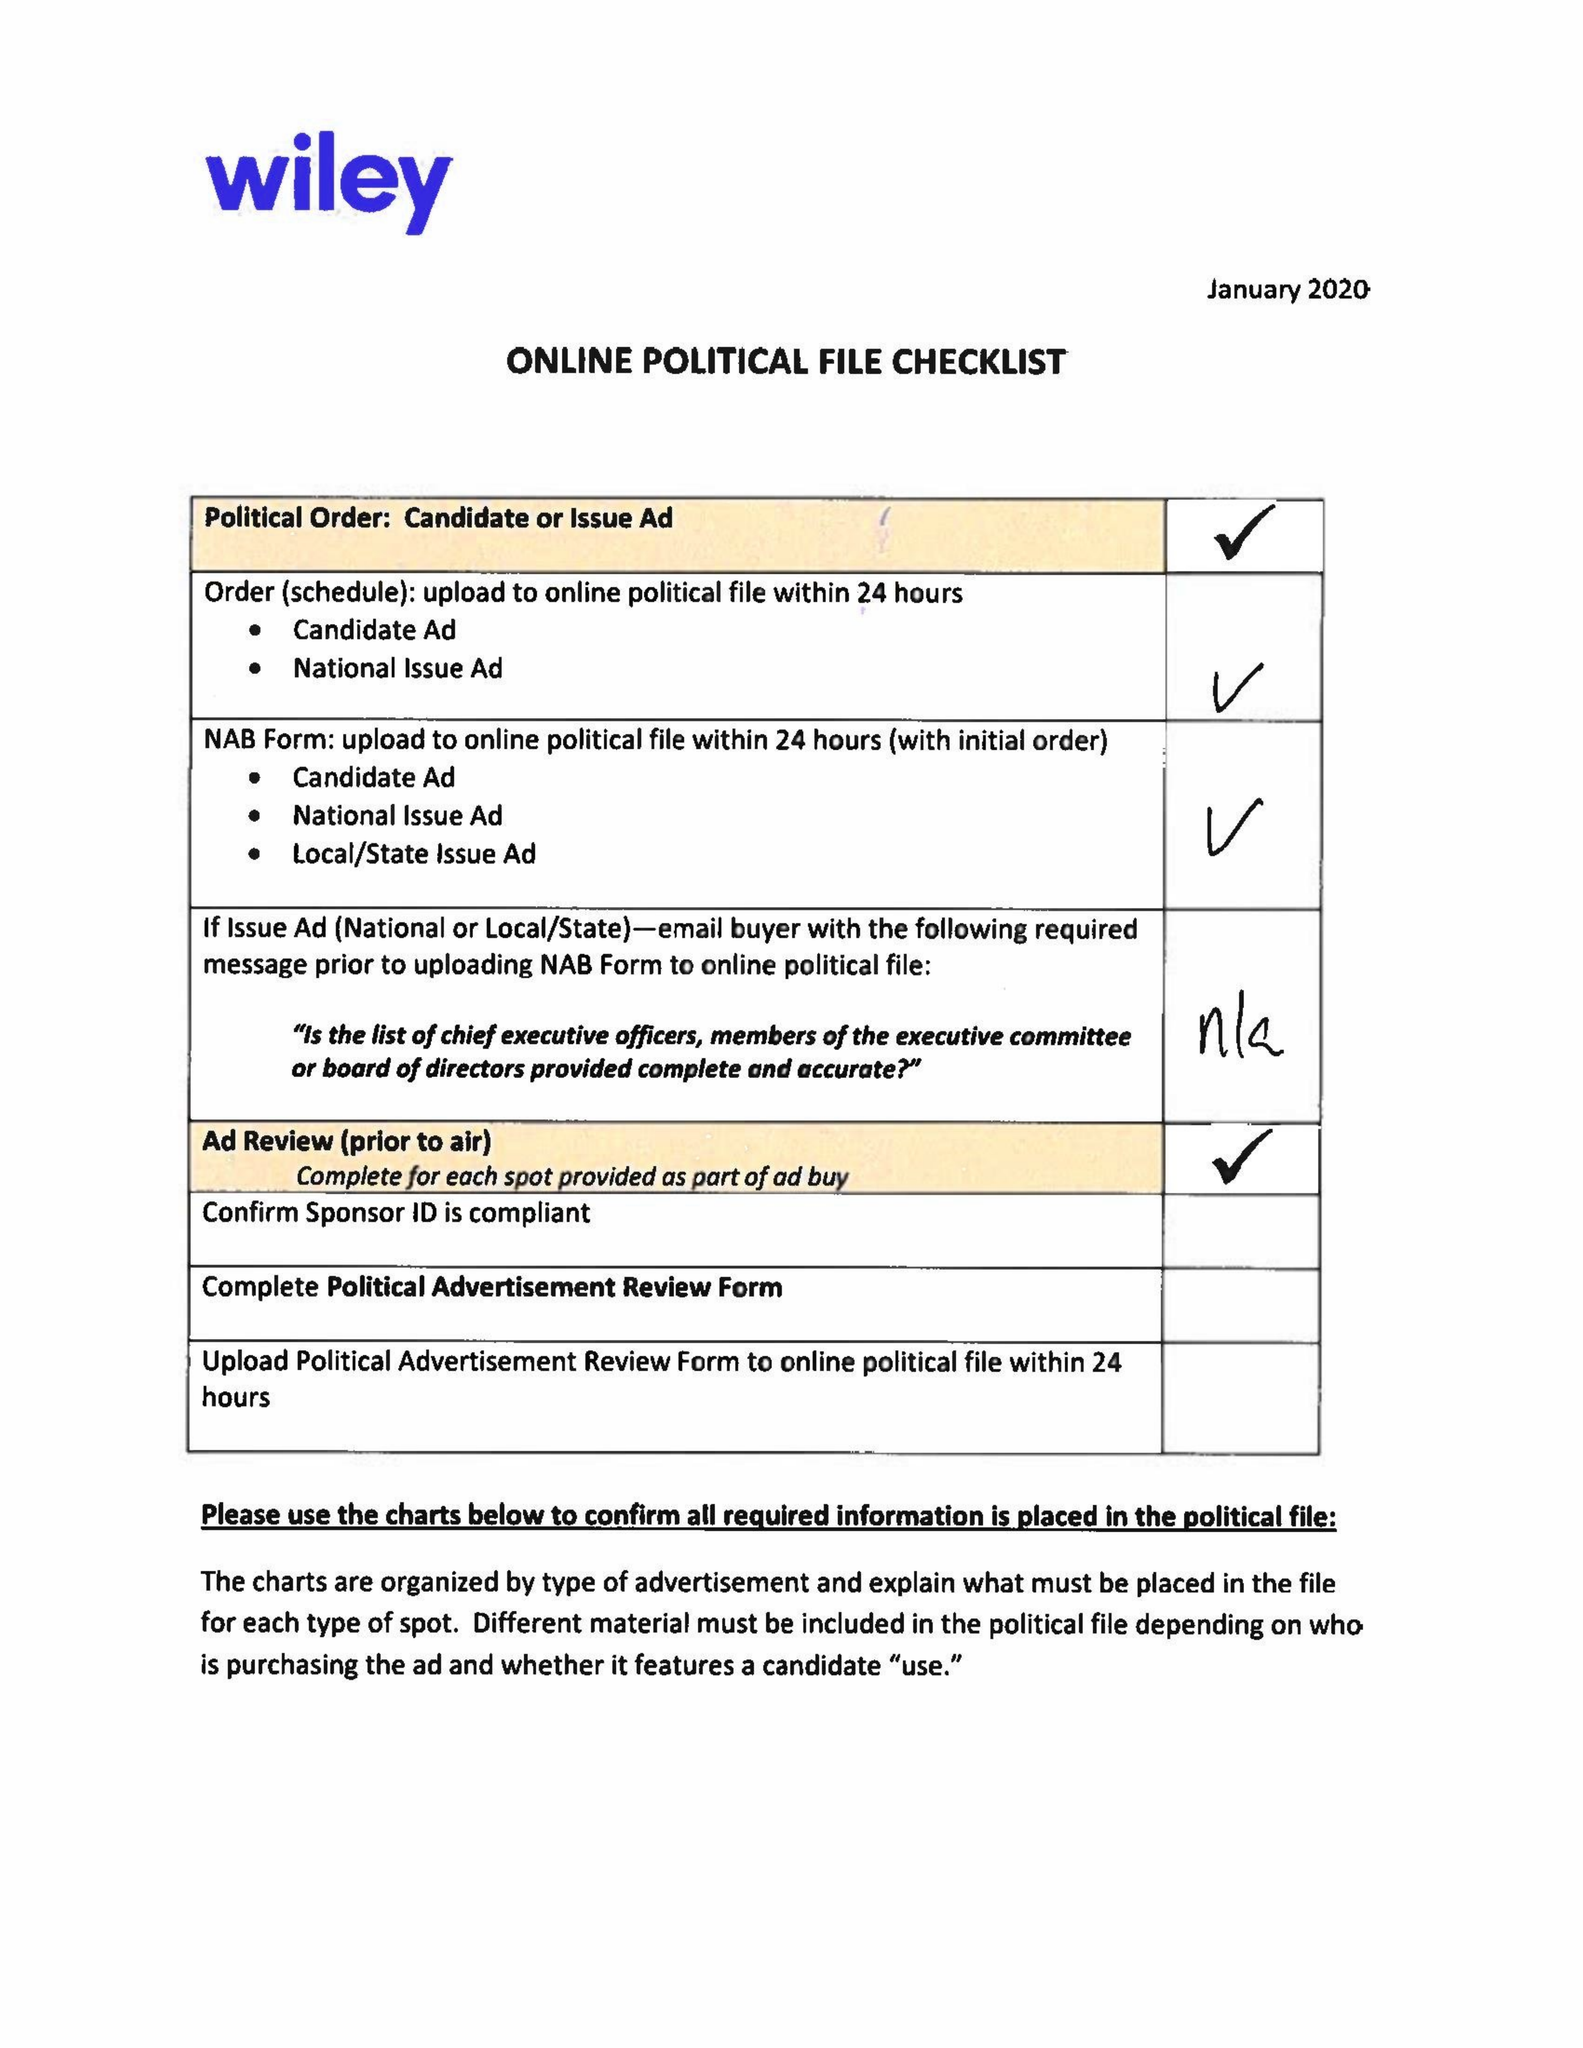What is the value for the gross_amount?
Answer the question using a single word or phrase. 12890.00 